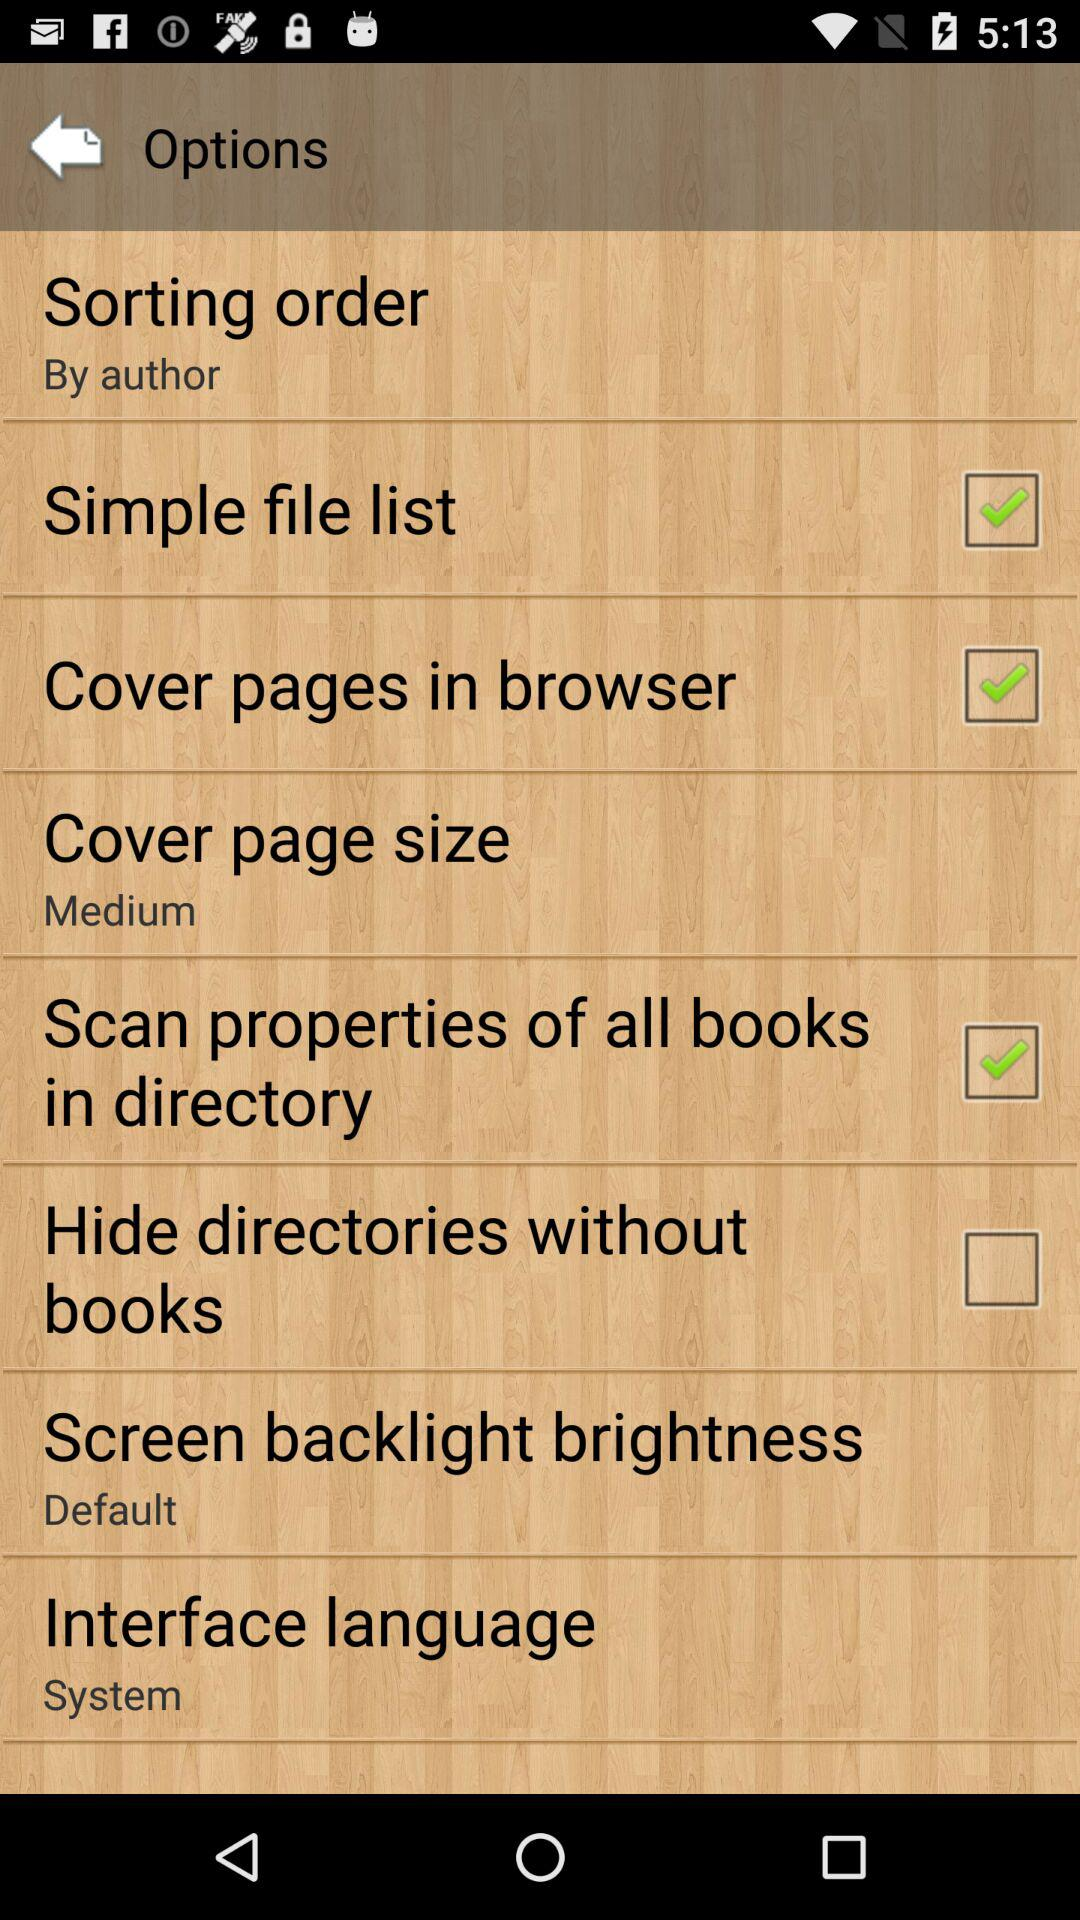What is the checked checkbox? The checked checkboxes are "Simple file list", "Cover pages in browser" and "Scan properties of all books in directory". 